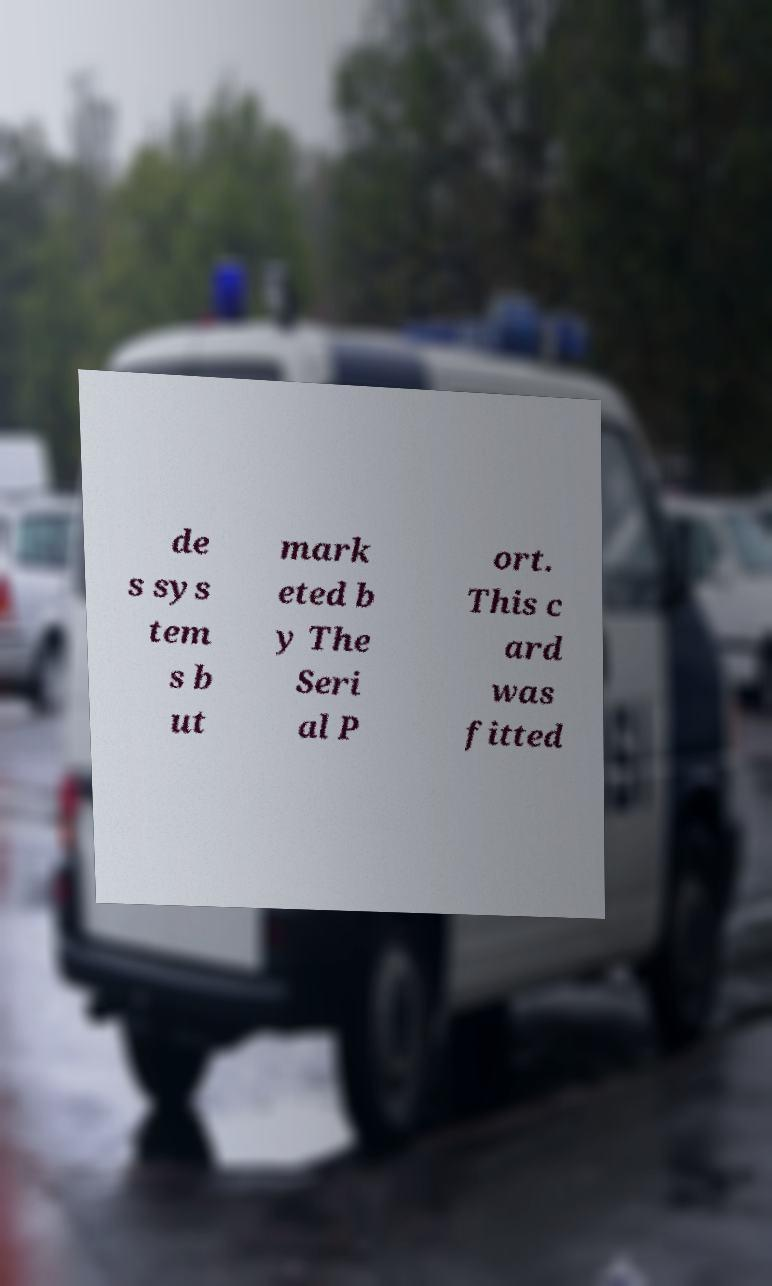Could you extract and type out the text from this image? de s sys tem s b ut mark eted b y The Seri al P ort. This c ard was fitted 